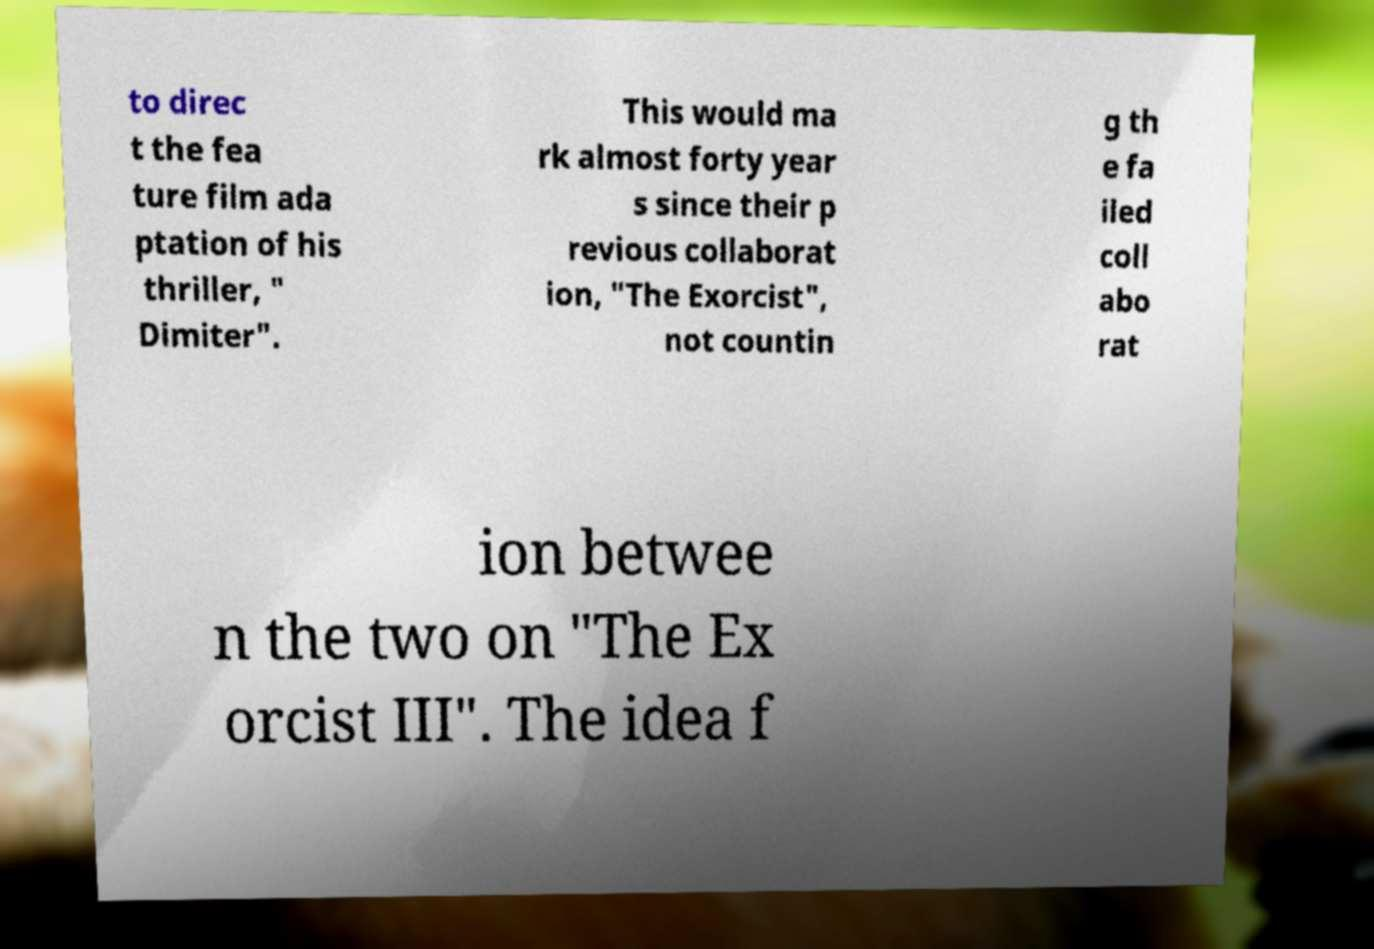There's text embedded in this image that I need extracted. Can you transcribe it verbatim? to direc t the fea ture film ada ptation of his thriller, " Dimiter". This would ma rk almost forty year s since their p revious collaborat ion, "The Exorcist", not countin g th e fa iled coll abo rat ion betwee n the two on "The Ex orcist III". The idea f 